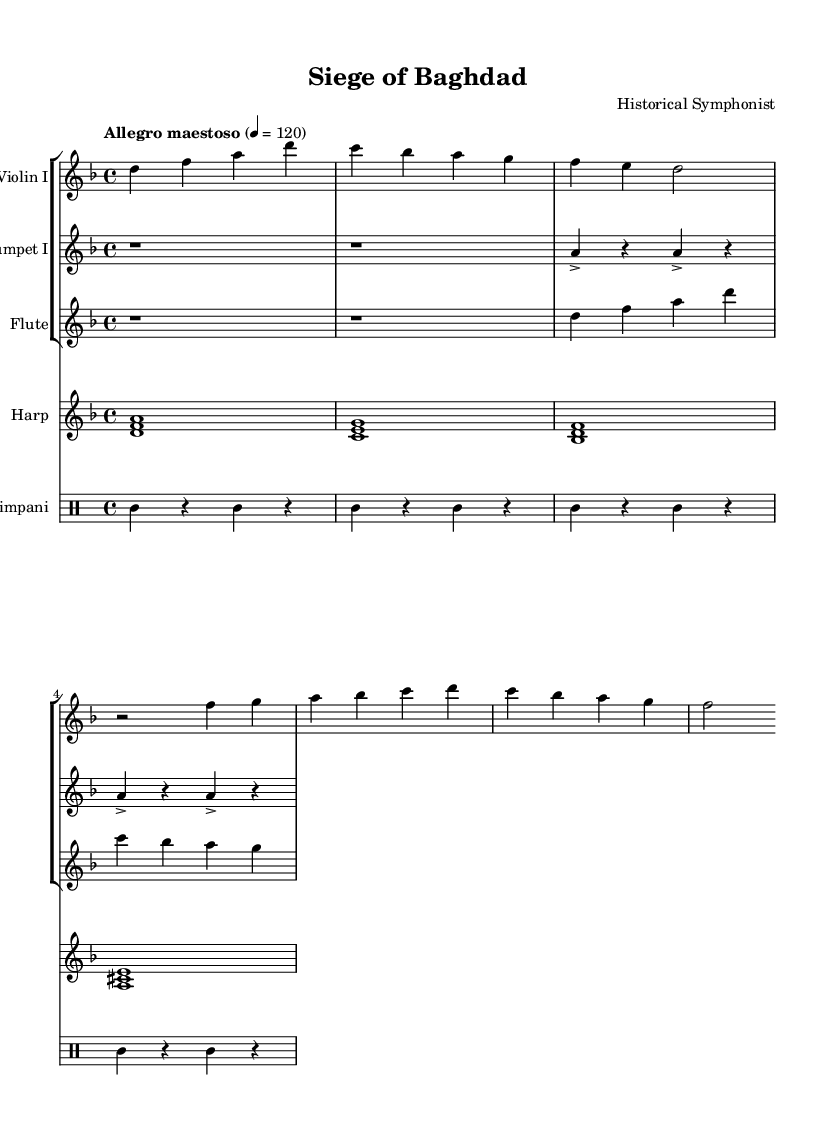What is the key signature of this music? The key signature is identified by looking at the placement of sharps or flats after the clef sign at the beginning of the staff. In this case, it indicates D minor, which has one flat (B flat).
Answer: D minor What is the time signature of this music? The time signature is found after the key signature at the beginning of the staff, represented by the numbers that indicate how many beats are in each measure. Here, the time signature is 4/4, meaning there are 4 beats per measure.
Answer: 4/4 What tempo marking is given for this piece? The tempo is marked in Italian at the beginning of the score, indicating the speed of the piece. In this score, it says "Allegro maestoso," which indicates a fast and majestic pace.
Answer: Allegro maestoso How many measures are in the violin I part? To determine the number of measures, count the number of vertical lines (bar lines) that separate the sections in the staff of the violin I part. The violin I part contains 4 measures.
Answer: 4 What is the dynamic marking for the harp part? Dynamic markings are usually indicated in the score to suggest the volume of each section. In this case, the harp part does not explicitly show dynamic markings, which implies a softer or gentle dynamics throughout the piece.
Answer: No dynamic marking What instruments are included in the score? The score lists the instruments at the beginning of each staff. In this particular piece, the instruments are Violin I, Trumpet I, Flute, Harp, and Timpani.
Answer: Violin I, Trumpet I, Flute, Harp, Timpani Which section in the score features the timpani? The timpani part is typically indicated in a separate staff, identifiable by its name listed at the beginning of the drum staff. In this score, the timpani is placed within a designated drum staff labeled "Timpani" at the end.
Answer: Timpani 